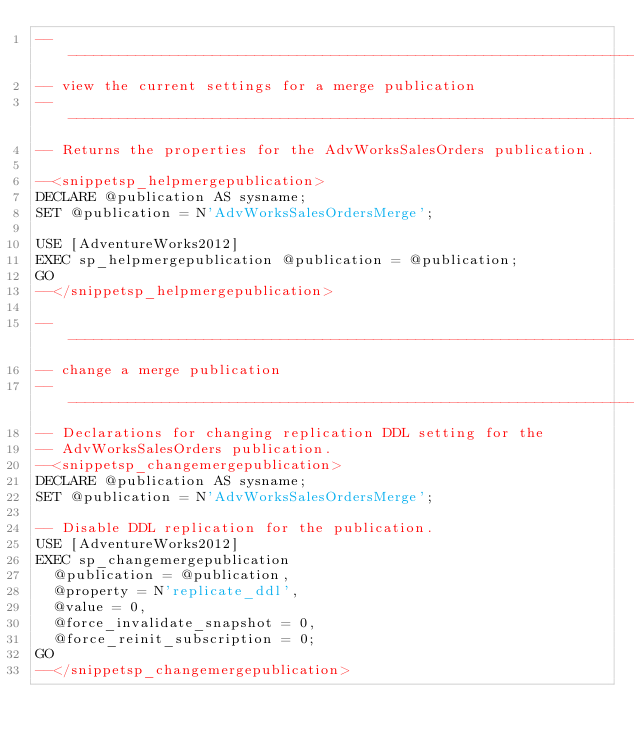Convert code to text. <code><loc_0><loc_0><loc_500><loc_500><_SQL_>--------------------------------------------------------------------------
-- view the current settings for a merge publication
--------------------------------------------------------------------------
-- Returns the properties for the AdvWorksSalesOrders publication.

--<snippetsp_helpmergepublication>
DECLARE @publication AS sysname;
SET @publication = N'AdvWorksSalesOrdersMerge';

USE [AdventureWorks2012]
EXEC sp_helpmergepublication @publication = @publication;
GO
--</snippetsp_helpmergepublication>

--------------------------------------------------------------------------
-- change a merge publication
--------------------------------------------------------------------------
-- Declarations for changing replication DDL setting for the 
-- AdvWorksSalesOrders publication.
--<snippetsp_changemergepublication>
DECLARE @publication AS sysname;
SET @publication = N'AdvWorksSalesOrdersMerge'; 

-- Disable DDL replication for the publication.
USE [AdventureWorks2012]
EXEC sp_changemergepublication 
  @publication = @publication, 
  @property = N'replicate_ddl', 
  @value = 0,
  @force_invalidate_snapshot = 0, 
  @force_reinit_subscription = 0;
GO
--</snippetsp_changemergepublication>
</code> 